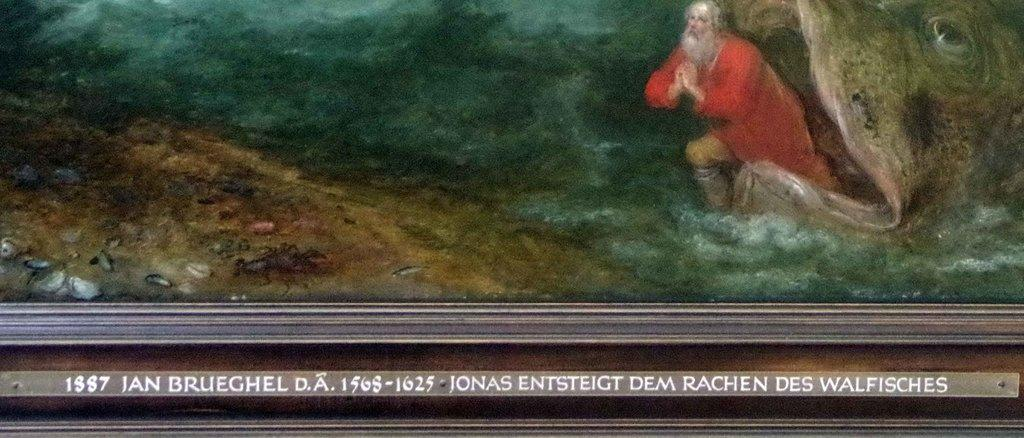What type of artwork is depicted in the image? The image is a painting. Can you describe the subject matter of the painting? There is a person in the painting. Does the person in the painting have a tail? There is no indication in the painting that the person has a tail. Is the person in the painting swimming in a lake? There is no lake or any reference to water in the painting. 